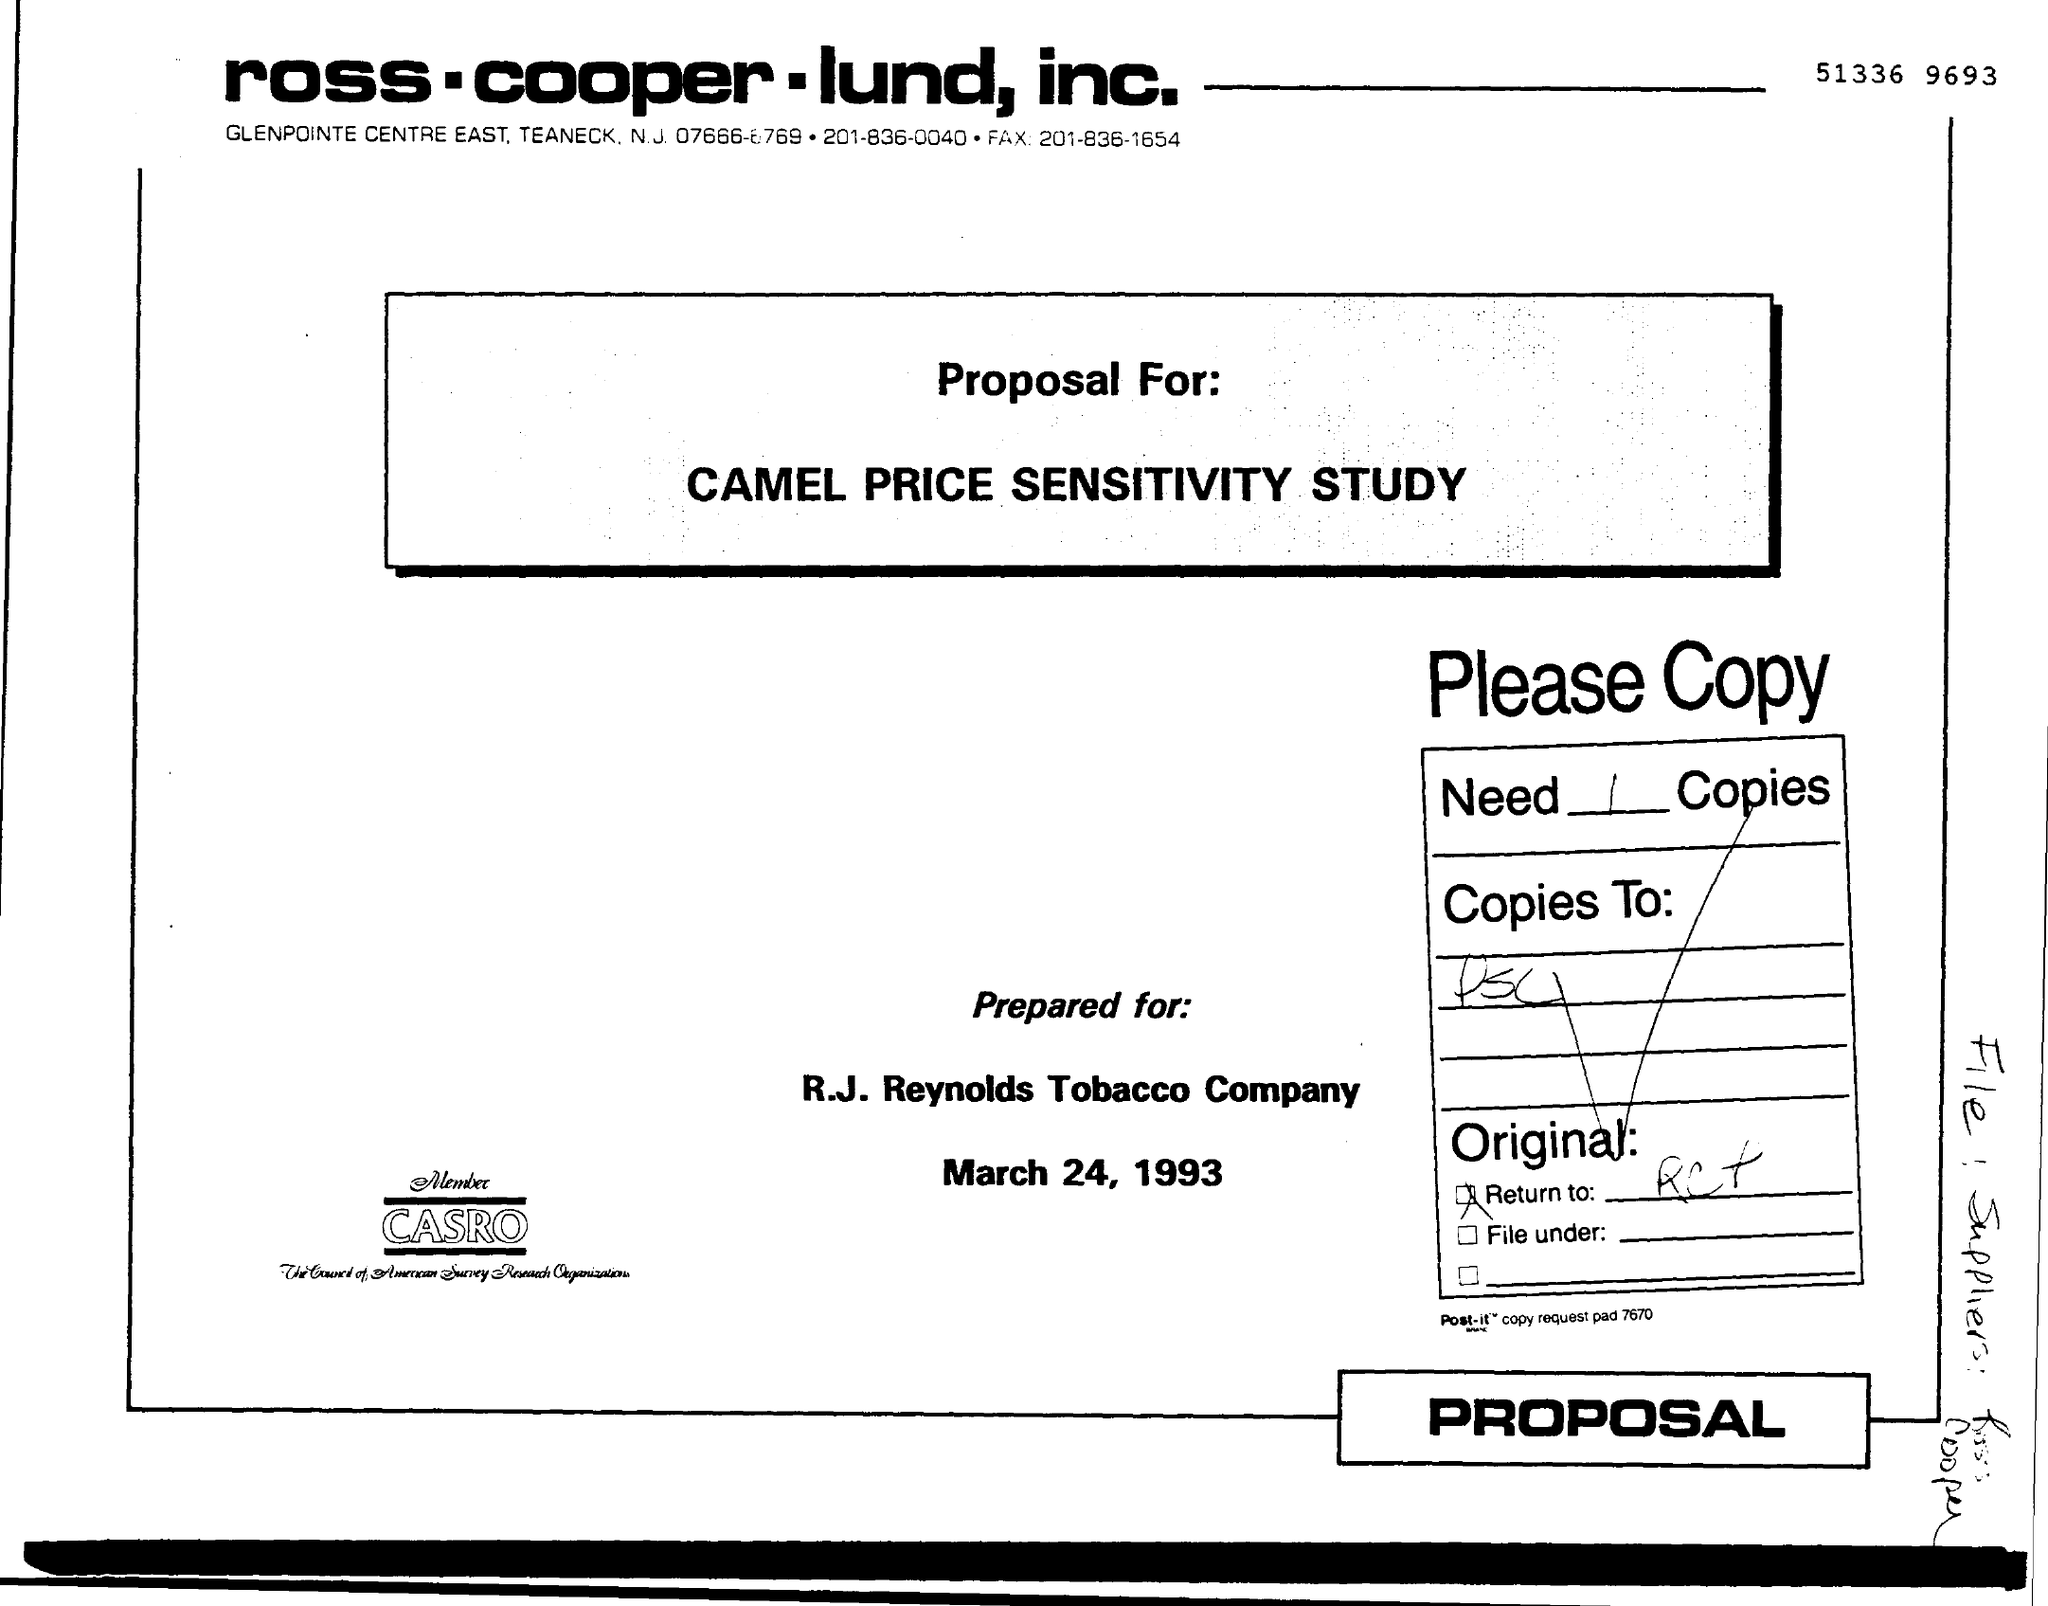What is the date on the document?
Provide a short and direct response. March 24, 1993. 